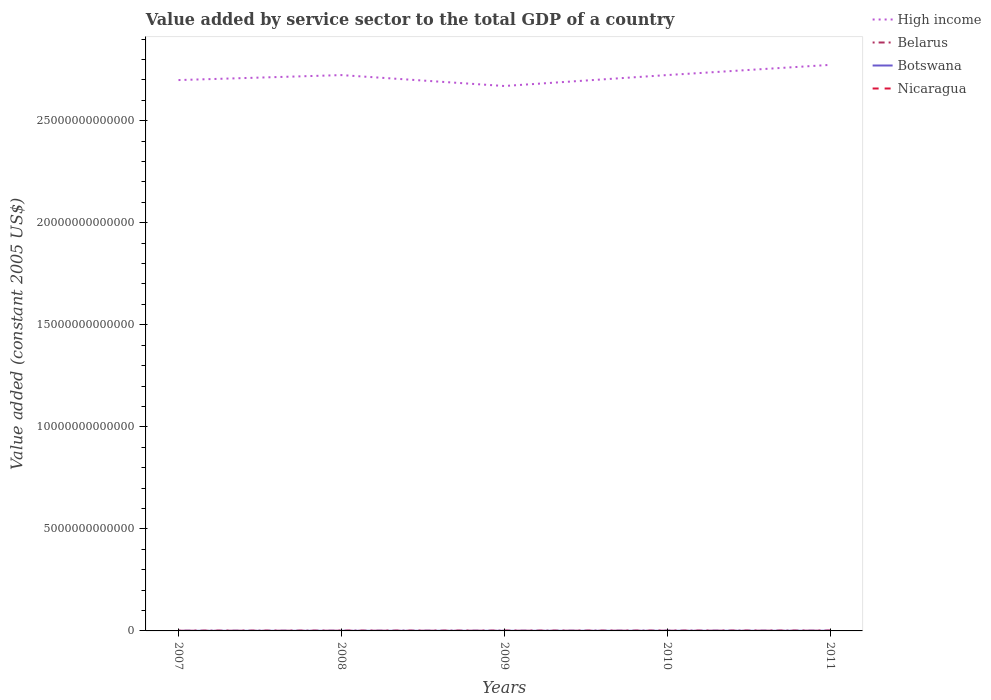Is the number of lines equal to the number of legend labels?
Keep it short and to the point. Yes. Across all years, what is the maximum value added by service sector in High income?
Your answer should be compact. 2.67e+13. What is the total value added by service sector in High income in the graph?
Your answer should be very brief. -7.44e+11. What is the difference between the highest and the second highest value added by service sector in Botswana?
Offer a terse response. 1.98e+09. What is the difference between the highest and the lowest value added by service sector in Belarus?
Offer a very short reply. 2. Is the value added by service sector in High income strictly greater than the value added by service sector in Botswana over the years?
Give a very brief answer. No. How many lines are there?
Your response must be concise. 4. What is the difference between two consecutive major ticks on the Y-axis?
Keep it short and to the point. 5.00e+12. Does the graph contain grids?
Your answer should be very brief. No. Where does the legend appear in the graph?
Your response must be concise. Top right. How many legend labels are there?
Your response must be concise. 4. What is the title of the graph?
Your response must be concise. Value added by service sector to the total GDP of a country. Does "Lao PDR" appear as one of the legend labels in the graph?
Your answer should be very brief. No. What is the label or title of the Y-axis?
Your answer should be compact. Value added (constant 2005 US$). What is the Value added (constant 2005 US$) of High income in 2007?
Provide a short and direct response. 2.70e+13. What is the Value added (constant 2005 US$) of Belarus in 2007?
Offer a terse response. 1.35e+1. What is the Value added (constant 2005 US$) in Botswana in 2007?
Provide a short and direct response. 5.49e+09. What is the Value added (constant 2005 US$) in Nicaragua in 2007?
Your answer should be compact. 3.76e+09. What is the Value added (constant 2005 US$) in High income in 2008?
Your answer should be very brief. 2.72e+13. What is the Value added (constant 2005 US$) in Belarus in 2008?
Give a very brief answer. 1.42e+1. What is the Value added (constant 2005 US$) of Botswana in 2008?
Your answer should be very brief. 6.08e+09. What is the Value added (constant 2005 US$) of Nicaragua in 2008?
Your answer should be very brief. 3.97e+09. What is the Value added (constant 2005 US$) of High income in 2009?
Provide a succinct answer. 2.67e+13. What is the Value added (constant 2005 US$) of Belarus in 2009?
Your response must be concise. 1.43e+1. What is the Value added (constant 2005 US$) in Botswana in 2009?
Give a very brief answer. 6.35e+09. What is the Value added (constant 2005 US$) in Nicaragua in 2009?
Give a very brief answer. 3.93e+09. What is the Value added (constant 2005 US$) in High income in 2010?
Give a very brief answer. 2.72e+13. What is the Value added (constant 2005 US$) of Belarus in 2010?
Make the answer very short. 1.52e+1. What is the Value added (constant 2005 US$) in Botswana in 2010?
Offer a terse response. 6.88e+09. What is the Value added (constant 2005 US$) of Nicaragua in 2010?
Your answer should be very brief. 4.13e+09. What is the Value added (constant 2005 US$) of High income in 2011?
Your answer should be compact. 2.77e+13. What is the Value added (constant 2005 US$) of Belarus in 2011?
Offer a very short reply. 1.65e+1. What is the Value added (constant 2005 US$) in Botswana in 2011?
Your answer should be compact. 7.47e+09. What is the Value added (constant 2005 US$) in Nicaragua in 2011?
Keep it short and to the point. 4.30e+09. Across all years, what is the maximum Value added (constant 2005 US$) of High income?
Ensure brevity in your answer.  2.77e+13. Across all years, what is the maximum Value added (constant 2005 US$) in Belarus?
Your response must be concise. 1.65e+1. Across all years, what is the maximum Value added (constant 2005 US$) in Botswana?
Your answer should be compact. 7.47e+09. Across all years, what is the maximum Value added (constant 2005 US$) of Nicaragua?
Make the answer very short. 4.30e+09. Across all years, what is the minimum Value added (constant 2005 US$) in High income?
Make the answer very short. 2.67e+13. Across all years, what is the minimum Value added (constant 2005 US$) of Belarus?
Offer a very short reply. 1.35e+1. Across all years, what is the minimum Value added (constant 2005 US$) of Botswana?
Your answer should be compact. 5.49e+09. Across all years, what is the minimum Value added (constant 2005 US$) in Nicaragua?
Your response must be concise. 3.76e+09. What is the total Value added (constant 2005 US$) in High income in the graph?
Keep it short and to the point. 1.36e+14. What is the total Value added (constant 2005 US$) of Belarus in the graph?
Offer a terse response. 7.37e+1. What is the total Value added (constant 2005 US$) of Botswana in the graph?
Offer a terse response. 3.23e+1. What is the total Value added (constant 2005 US$) of Nicaragua in the graph?
Your answer should be compact. 2.01e+1. What is the difference between the Value added (constant 2005 US$) of High income in 2007 and that in 2008?
Give a very brief answer. -2.44e+11. What is the difference between the Value added (constant 2005 US$) of Belarus in 2007 and that in 2008?
Offer a terse response. -6.53e+08. What is the difference between the Value added (constant 2005 US$) of Botswana in 2007 and that in 2008?
Offer a very short reply. -5.85e+08. What is the difference between the Value added (constant 2005 US$) in Nicaragua in 2007 and that in 2008?
Your answer should be compact. -2.14e+08. What is the difference between the Value added (constant 2005 US$) of High income in 2007 and that in 2009?
Your answer should be compact. 2.90e+11. What is the difference between the Value added (constant 2005 US$) in Belarus in 2007 and that in 2009?
Offer a very short reply. -7.69e+08. What is the difference between the Value added (constant 2005 US$) in Botswana in 2007 and that in 2009?
Your answer should be very brief. -8.61e+08. What is the difference between the Value added (constant 2005 US$) in Nicaragua in 2007 and that in 2009?
Your response must be concise. -1.70e+08. What is the difference between the Value added (constant 2005 US$) of High income in 2007 and that in 2010?
Offer a very short reply. -2.45e+11. What is the difference between the Value added (constant 2005 US$) of Belarus in 2007 and that in 2010?
Give a very brief answer. -1.70e+09. What is the difference between the Value added (constant 2005 US$) of Botswana in 2007 and that in 2010?
Offer a very short reply. -1.39e+09. What is the difference between the Value added (constant 2005 US$) of Nicaragua in 2007 and that in 2010?
Offer a terse response. -3.67e+08. What is the difference between the Value added (constant 2005 US$) of High income in 2007 and that in 2011?
Give a very brief answer. -7.44e+11. What is the difference between the Value added (constant 2005 US$) in Belarus in 2007 and that in 2011?
Provide a short and direct response. -2.93e+09. What is the difference between the Value added (constant 2005 US$) in Botswana in 2007 and that in 2011?
Provide a short and direct response. -1.98e+09. What is the difference between the Value added (constant 2005 US$) of Nicaragua in 2007 and that in 2011?
Give a very brief answer. -5.40e+08. What is the difference between the Value added (constant 2005 US$) of High income in 2008 and that in 2009?
Give a very brief answer. 5.34e+11. What is the difference between the Value added (constant 2005 US$) of Belarus in 2008 and that in 2009?
Provide a short and direct response. -1.16e+08. What is the difference between the Value added (constant 2005 US$) in Botswana in 2008 and that in 2009?
Give a very brief answer. -2.76e+08. What is the difference between the Value added (constant 2005 US$) in Nicaragua in 2008 and that in 2009?
Your answer should be very brief. 4.43e+07. What is the difference between the Value added (constant 2005 US$) of High income in 2008 and that in 2010?
Offer a terse response. -1.33e+09. What is the difference between the Value added (constant 2005 US$) of Belarus in 2008 and that in 2010?
Offer a terse response. -1.05e+09. What is the difference between the Value added (constant 2005 US$) in Botswana in 2008 and that in 2010?
Make the answer very short. -8.05e+08. What is the difference between the Value added (constant 2005 US$) of Nicaragua in 2008 and that in 2010?
Your answer should be compact. -1.53e+08. What is the difference between the Value added (constant 2005 US$) in High income in 2008 and that in 2011?
Provide a succinct answer. -5.01e+11. What is the difference between the Value added (constant 2005 US$) of Belarus in 2008 and that in 2011?
Offer a very short reply. -2.28e+09. What is the difference between the Value added (constant 2005 US$) in Botswana in 2008 and that in 2011?
Give a very brief answer. -1.39e+09. What is the difference between the Value added (constant 2005 US$) in Nicaragua in 2008 and that in 2011?
Your answer should be compact. -3.26e+08. What is the difference between the Value added (constant 2005 US$) of High income in 2009 and that in 2010?
Your answer should be compact. -5.36e+11. What is the difference between the Value added (constant 2005 US$) of Belarus in 2009 and that in 2010?
Your response must be concise. -9.30e+08. What is the difference between the Value added (constant 2005 US$) in Botswana in 2009 and that in 2010?
Offer a terse response. -5.29e+08. What is the difference between the Value added (constant 2005 US$) in Nicaragua in 2009 and that in 2010?
Offer a terse response. -1.97e+08. What is the difference between the Value added (constant 2005 US$) in High income in 2009 and that in 2011?
Offer a very short reply. -1.03e+12. What is the difference between the Value added (constant 2005 US$) of Belarus in 2009 and that in 2011?
Provide a short and direct response. -2.16e+09. What is the difference between the Value added (constant 2005 US$) in Botswana in 2009 and that in 2011?
Ensure brevity in your answer.  -1.12e+09. What is the difference between the Value added (constant 2005 US$) of Nicaragua in 2009 and that in 2011?
Make the answer very short. -3.70e+08. What is the difference between the Value added (constant 2005 US$) in High income in 2010 and that in 2011?
Provide a succinct answer. -4.99e+11. What is the difference between the Value added (constant 2005 US$) in Belarus in 2010 and that in 2011?
Provide a short and direct response. -1.23e+09. What is the difference between the Value added (constant 2005 US$) in Botswana in 2010 and that in 2011?
Your answer should be compact. -5.90e+08. What is the difference between the Value added (constant 2005 US$) in Nicaragua in 2010 and that in 2011?
Give a very brief answer. -1.73e+08. What is the difference between the Value added (constant 2005 US$) of High income in 2007 and the Value added (constant 2005 US$) of Belarus in 2008?
Offer a very short reply. 2.70e+13. What is the difference between the Value added (constant 2005 US$) in High income in 2007 and the Value added (constant 2005 US$) in Botswana in 2008?
Give a very brief answer. 2.70e+13. What is the difference between the Value added (constant 2005 US$) in High income in 2007 and the Value added (constant 2005 US$) in Nicaragua in 2008?
Offer a very short reply. 2.70e+13. What is the difference between the Value added (constant 2005 US$) of Belarus in 2007 and the Value added (constant 2005 US$) of Botswana in 2008?
Your answer should be compact. 7.46e+09. What is the difference between the Value added (constant 2005 US$) in Belarus in 2007 and the Value added (constant 2005 US$) in Nicaragua in 2008?
Offer a very short reply. 9.56e+09. What is the difference between the Value added (constant 2005 US$) of Botswana in 2007 and the Value added (constant 2005 US$) of Nicaragua in 2008?
Make the answer very short. 1.52e+09. What is the difference between the Value added (constant 2005 US$) of High income in 2007 and the Value added (constant 2005 US$) of Belarus in 2009?
Your answer should be very brief. 2.70e+13. What is the difference between the Value added (constant 2005 US$) in High income in 2007 and the Value added (constant 2005 US$) in Botswana in 2009?
Provide a short and direct response. 2.70e+13. What is the difference between the Value added (constant 2005 US$) of High income in 2007 and the Value added (constant 2005 US$) of Nicaragua in 2009?
Keep it short and to the point. 2.70e+13. What is the difference between the Value added (constant 2005 US$) of Belarus in 2007 and the Value added (constant 2005 US$) of Botswana in 2009?
Your answer should be very brief. 7.18e+09. What is the difference between the Value added (constant 2005 US$) of Belarus in 2007 and the Value added (constant 2005 US$) of Nicaragua in 2009?
Make the answer very short. 9.61e+09. What is the difference between the Value added (constant 2005 US$) of Botswana in 2007 and the Value added (constant 2005 US$) of Nicaragua in 2009?
Provide a succinct answer. 1.56e+09. What is the difference between the Value added (constant 2005 US$) of High income in 2007 and the Value added (constant 2005 US$) of Belarus in 2010?
Provide a short and direct response. 2.70e+13. What is the difference between the Value added (constant 2005 US$) of High income in 2007 and the Value added (constant 2005 US$) of Botswana in 2010?
Keep it short and to the point. 2.70e+13. What is the difference between the Value added (constant 2005 US$) of High income in 2007 and the Value added (constant 2005 US$) of Nicaragua in 2010?
Offer a terse response. 2.70e+13. What is the difference between the Value added (constant 2005 US$) of Belarus in 2007 and the Value added (constant 2005 US$) of Botswana in 2010?
Provide a short and direct response. 6.66e+09. What is the difference between the Value added (constant 2005 US$) in Belarus in 2007 and the Value added (constant 2005 US$) in Nicaragua in 2010?
Give a very brief answer. 9.41e+09. What is the difference between the Value added (constant 2005 US$) in Botswana in 2007 and the Value added (constant 2005 US$) in Nicaragua in 2010?
Give a very brief answer. 1.37e+09. What is the difference between the Value added (constant 2005 US$) in High income in 2007 and the Value added (constant 2005 US$) in Belarus in 2011?
Make the answer very short. 2.70e+13. What is the difference between the Value added (constant 2005 US$) in High income in 2007 and the Value added (constant 2005 US$) in Botswana in 2011?
Give a very brief answer. 2.70e+13. What is the difference between the Value added (constant 2005 US$) in High income in 2007 and the Value added (constant 2005 US$) in Nicaragua in 2011?
Your answer should be very brief. 2.70e+13. What is the difference between the Value added (constant 2005 US$) of Belarus in 2007 and the Value added (constant 2005 US$) of Botswana in 2011?
Your answer should be very brief. 6.07e+09. What is the difference between the Value added (constant 2005 US$) in Belarus in 2007 and the Value added (constant 2005 US$) in Nicaragua in 2011?
Keep it short and to the point. 9.24e+09. What is the difference between the Value added (constant 2005 US$) of Botswana in 2007 and the Value added (constant 2005 US$) of Nicaragua in 2011?
Your answer should be compact. 1.19e+09. What is the difference between the Value added (constant 2005 US$) in High income in 2008 and the Value added (constant 2005 US$) in Belarus in 2009?
Your answer should be compact. 2.72e+13. What is the difference between the Value added (constant 2005 US$) in High income in 2008 and the Value added (constant 2005 US$) in Botswana in 2009?
Your answer should be very brief. 2.72e+13. What is the difference between the Value added (constant 2005 US$) in High income in 2008 and the Value added (constant 2005 US$) in Nicaragua in 2009?
Provide a short and direct response. 2.72e+13. What is the difference between the Value added (constant 2005 US$) of Belarus in 2008 and the Value added (constant 2005 US$) of Botswana in 2009?
Your response must be concise. 7.84e+09. What is the difference between the Value added (constant 2005 US$) of Belarus in 2008 and the Value added (constant 2005 US$) of Nicaragua in 2009?
Make the answer very short. 1.03e+1. What is the difference between the Value added (constant 2005 US$) in Botswana in 2008 and the Value added (constant 2005 US$) in Nicaragua in 2009?
Offer a very short reply. 2.15e+09. What is the difference between the Value added (constant 2005 US$) in High income in 2008 and the Value added (constant 2005 US$) in Belarus in 2010?
Your response must be concise. 2.72e+13. What is the difference between the Value added (constant 2005 US$) of High income in 2008 and the Value added (constant 2005 US$) of Botswana in 2010?
Offer a very short reply. 2.72e+13. What is the difference between the Value added (constant 2005 US$) in High income in 2008 and the Value added (constant 2005 US$) in Nicaragua in 2010?
Provide a short and direct response. 2.72e+13. What is the difference between the Value added (constant 2005 US$) of Belarus in 2008 and the Value added (constant 2005 US$) of Botswana in 2010?
Offer a very short reply. 7.31e+09. What is the difference between the Value added (constant 2005 US$) in Belarus in 2008 and the Value added (constant 2005 US$) in Nicaragua in 2010?
Ensure brevity in your answer.  1.01e+1. What is the difference between the Value added (constant 2005 US$) in Botswana in 2008 and the Value added (constant 2005 US$) in Nicaragua in 2010?
Ensure brevity in your answer.  1.95e+09. What is the difference between the Value added (constant 2005 US$) in High income in 2008 and the Value added (constant 2005 US$) in Belarus in 2011?
Keep it short and to the point. 2.72e+13. What is the difference between the Value added (constant 2005 US$) in High income in 2008 and the Value added (constant 2005 US$) in Botswana in 2011?
Give a very brief answer. 2.72e+13. What is the difference between the Value added (constant 2005 US$) of High income in 2008 and the Value added (constant 2005 US$) of Nicaragua in 2011?
Keep it short and to the point. 2.72e+13. What is the difference between the Value added (constant 2005 US$) in Belarus in 2008 and the Value added (constant 2005 US$) in Botswana in 2011?
Keep it short and to the point. 6.72e+09. What is the difference between the Value added (constant 2005 US$) of Belarus in 2008 and the Value added (constant 2005 US$) of Nicaragua in 2011?
Your answer should be very brief. 9.89e+09. What is the difference between the Value added (constant 2005 US$) of Botswana in 2008 and the Value added (constant 2005 US$) of Nicaragua in 2011?
Offer a terse response. 1.78e+09. What is the difference between the Value added (constant 2005 US$) of High income in 2009 and the Value added (constant 2005 US$) of Belarus in 2010?
Make the answer very short. 2.67e+13. What is the difference between the Value added (constant 2005 US$) of High income in 2009 and the Value added (constant 2005 US$) of Botswana in 2010?
Make the answer very short. 2.67e+13. What is the difference between the Value added (constant 2005 US$) of High income in 2009 and the Value added (constant 2005 US$) of Nicaragua in 2010?
Give a very brief answer. 2.67e+13. What is the difference between the Value added (constant 2005 US$) in Belarus in 2009 and the Value added (constant 2005 US$) in Botswana in 2010?
Ensure brevity in your answer.  7.42e+09. What is the difference between the Value added (constant 2005 US$) in Belarus in 2009 and the Value added (constant 2005 US$) in Nicaragua in 2010?
Give a very brief answer. 1.02e+1. What is the difference between the Value added (constant 2005 US$) in Botswana in 2009 and the Value added (constant 2005 US$) in Nicaragua in 2010?
Make the answer very short. 2.23e+09. What is the difference between the Value added (constant 2005 US$) in High income in 2009 and the Value added (constant 2005 US$) in Belarus in 2011?
Provide a short and direct response. 2.67e+13. What is the difference between the Value added (constant 2005 US$) of High income in 2009 and the Value added (constant 2005 US$) of Botswana in 2011?
Give a very brief answer. 2.67e+13. What is the difference between the Value added (constant 2005 US$) in High income in 2009 and the Value added (constant 2005 US$) in Nicaragua in 2011?
Provide a short and direct response. 2.67e+13. What is the difference between the Value added (constant 2005 US$) in Belarus in 2009 and the Value added (constant 2005 US$) in Botswana in 2011?
Make the answer very short. 6.83e+09. What is the difference between the Value added (constant 2005 US$) in Belarus in 2009 and the Value added (constant 2005 US$) in Nicaragua in 2011?
Give a very brief answer. 1.00e+1. What is the difference between the Value added (constant 2005 US$) of Botswana in 2009 and the Value added (constant 2005 US$) of Nicaragua in 2011?
Ensure brevity in your answer.  2.05e+09. What is the difference between the Value added (constant 2005 US$) of High income in 2010 and the Value added (constant 2005 US$) of Belarus in 2011?
Make the answer very short. 2.72e+13. What is the difference between the Value added (constant 2005 US$) of High income in 2010 and the Value added (constant 2005 US$) of Botswana in 2011?
Make the answer very short. 2.72e+13. What is the difference between the Value added (constant 2005 US$) of High income in 2010 and the Value added (constant 2005 US$) of Nicaragua in 2011?
Provide a succinct answer. 2.72e+13. What is the difference between the Value added (constant 2005 US$) of Belarus in 2010 and the Value added (constant 2005 US$) of Botswana in 2011?
Make the answer very short. 7.76e+09. What is the difference between the Value added (constant 2005 US$) of Belarus in 2010 and the Value added (constant 2005 US$) of Nicaragua in 2011?
Your answer should be very brief. 1.09e+1. What is the difference between the Value added (constant 2005 US$) of Botswana in 2010 and the Value added (constant 2005 US$) of Nicaragua in 2011?
Ensure brevity in your answer.  2.58e+09. What is the average Value added (constant 2005 US$) of High income per year?
Provide a succinct answer. 2.72e+13. What is the average Value added (constant 2005 US$) of Belarus per year?
Your response must be concise. 1.47e+1. What is the average Value added (constant 2005 US$) of Botswana per year?
Give a very brief answer. 6.46e+09. What is the average Value added (constant 2005 US$) in Nicaragua per year?
Your answer should be very brief. 4.02e+09. In the year 2007, what is the difference between the Value added (constant 2005 US$) in High income and Value added (constant 2005 US$) in Belarus?
Your answer should be compact. 2.70e+13. In the year 2007, what is the difference between the Value added (constant 2005 US$) of High income and Value added (constant 2005 US$) of Botswana?
Your response must be concise. 2.70e+13. In the year 2007, what is the difference between the Value added (constant 2005 US$) in High income and Value added (constant 2005 US$) in Nicaragua?
Offer a very short reply. 2.70e+13. In the year 2007, what is the difference between the Value added (constant 2005 US$) in Belarus and Value added (constant 2005 US$) in Botswana?
Provide a succinct answer. 8.04e+09. In the year 2007, what is the difference between the Value added (constant 2005 US$) in Belarus and Value added (constant 2005 US$) in Nicaragua?
Make the answer very short. 9.78e+09. In the year 2007, what is the difference between the Value added (constant 2005 US$) in Botswana and Value added (constant 2005 US$) in Nicaragua?
Provide a short and direct response. 1.73e+09. In the year 2008, what is the difference between the Value added (constant 2005 US$) in High income and Value added (constant 2005 US$) in Belarus?
Keep it short and to the point. 2.72e+13. In the year 2008, what is the difference between the Value added (constant 2005 US$) of High income and Value added (constant 2005 US$) of Botswana?
Your response must be concise. 2.72e+13. In the year 2008, what is the difference between the Value added (constant 2005 US$) in High income and Value added (constant 2005 US$) in Nicaragua?
Provide a short and direct response. 2.72e+13. In the year 2008, what is the difference between the Value added (constant 2005 US$) in Belarus and Value added (constant 2005 US$) in Botswana?
Give a very brief answer. 8.11e+09. In the year 2008, what is the difference between the Value added (constant 2005 US$) in Belarus and Value added (constant 2005 US$) in Nicaragua?
Offer a very short reply. 1.02e+1. In the year 2008, what is the difference between the Value added (constant 2005 US$) of Botswana and Value added (constant 2005 US$) of Nicaragua?
Keep it short and to the point. 2.10e+09. In the year 2009, what is the difference between the Value added (constant 2005 US$) of High income and Value added (constant 2005 US$) of Belarus?
Offer a very short reply. 2.67e+13. In the year 2009, what is the difference between the Value added (constant 2005 US$) of High income and Value added (constant 2005 US$) of Botswana?
Offer a terse response. 2.67e+13. In the year 2009, what is the difference between the Value added (constant 2005 US$) of High income and Value added (constant 2005 US$) of Nicaragua?
Your answer should be compact. 2.67e+13. In the year 2009, what is the difference between the Value added (constant 2005 US$) of Belarus and Value added (constant 2005 US$) of Botswana?
Your answer should be very brief. 7.95e+09. In the year 2009, what is the difference between the Value added (constant 2005 US$) in Belarus and Value added (constant 2005 US$) in Nicaragua?
Your answer should be very brief. 1.04e+1. In the year 2009, what is the difference between the Value added (constant 2005 US$) in Botswana and Value added (constant 2005 US$) in Nicaragua?
Keep it short and to the point. 2.42e+09. In the year 2010, what is the difference between the Value added (constant 2005 US$) of High income and Value added (constant 2005 US$) of Belarus?
Offer a terse response. 2.72e+13. In the year 2010, what is the difference between the Value added (constant 2005 US$) in High income and Value added (constant 2005 US$) in Botswana?
Offer a very short reply. 2.72e+13. In the year 2010, what is the difference between the Value added (constant 2005 US$) of High income and Value added (constant 2005 US$) of Nicaragua?
Keep it short and to the point. 2.72e+13. In the year 2010, what is the difference between the Value added (constant 2005 US$) of Belarus and Value added (constant 2005 US$) of Botswana?
Provide a succinct answer. 8.35e+09. In the year 2010, what is the difference between the Value added (constant 2005 US$) of Belarus and Value added (constant 2005 US$) of Nicaragua?
Provide a short and direct response. 1.11e+1. In the year 2010, what is the difference between the Value added (constant 2005 US$) of Botswana and Value added (constant 2005 US$) of Nicaragua?
Ensure brevity in your answer.  2.76e+09. In the year 2011, what is the difference between the Value added (constant 2005 US$) of High income and Value added (constant 2005 US$) of Belarus?
Keep it short and to the point. 2.77e+13. In the year 2011, what is the difference between the Value added (constant 2005 US$) of High income and Value added (constant 2005 US$) of Botswana?
Your answer should be very brief. 2.77e+13. In the year 2011, what is the difference between the Value added (constant 2005 US$) of High income and Value added (constant 2005 US$) of Nicaragua?
Provide a short and direct response. 2.77e+13. In the year 2011, what is the difference between the Value added (constant 2005 US$) of Belarus and Value added (constant 2005 US$) of Botswana?
Keep it short and to the point. 9.00e+09. In the year 2011, what is the difference between the Value added (constant 2005 US$) of Belarus and Value added (constant 2005 US$) of Nicaragua?
Your answer should be compact. 1.22e+1. In the year 2011, what is the difference between the Value added (constant 2005 US$) in Botswana and Value added (constant 2005 US$) in Nicaragua?
Your response must be concise. 3.17e+09. What is the ratio of the Value added (constant 2005 US$) in Belarus in 2007 to that in 2008?
Offer a terse response. 0.95. What is the ratio of the Value added (constant 2005 US$) in Botswana in 2007 to that in 2008?
Provide a short and direct response. 0.9. What is the ratio of the Value added (constant 2005 US$) in Nicaragua in 2007 to that in 2008?
Keep it short and to the point. 0.95. What is the ratio of the Value added (constant 2005 US$) in High income in 2007 to that in 2009?
Make the answer very short. 1.01. What is the ratio of the Value added (constant 2005 US$) of Belarus in 2007 to that in 2009?
Ensure brevity in your answer.  0.95. What is the ratio of the Value added (constant 2005 US$) of Botswana in 2007 to that in 2009?
Your answer should be compact. 0.86. What is the ratio of the Value added (constant 2005 US$) of Nicaragua in 2007 to that in 2009?
Make the answer very short. 0.96. What is the ratio of the Value added (constant 2005 US$) of High income in 2007 to that in 2010?
Ensure brevity in your answer.  0.99. What is the ratio of the Value added (constant 2005 US$) in Belarus in 2007 to that in 2010?
Provide a short and direct response. 0.89. What is the ratio of the Value added (constant 2005 US$) in Botswana in 2007 to that in 2010?
Provide a succinct answer. 0.8. What is the ratio of the Value added (constant 2005 US$) in Nicaragua in 2007 to that in 2010?
Keep it short and to the point. 0.91. What is the ratio of the Value added (constant 2005 US$) of High income in 2007 to that in 2011?
Your response must be concise. 0.97. What is the ratio of the Value added (constant 2005 US$) of Belarus in 2007 to that in 2011?
Make the answer very short. 0.82. What is the ratio of the Value added (constant 2005 US$) of Botswana in 2007 to that in 2011?
Keep it short and to the point. 0.74. What is the ratio of the Value added (constant 2005 US$) of Nicaragua in 2007 to that in 2011?
Your answer should be compact. 0.87. What is the ratio of the Value added (constant 2005 US$) of Botswana in 2008 to that in 2009?
Keep it short and to the point. 0.96. What is the ratio of the Value added (constant 2005 US$) in Nicaragua in 2008 to that in 2009?
Offer a terse response. 1.01. What is the ratio of the Value added (constant 2005 US$) in High income in 2008 to that in 2010?
Your response must be concise. 1. What is the ratio of the Value added (constant 2005 US$) of Belarus in 2008 to that in 2010?
Your answer should be very brief. 0.93. What is the ratio of the Value added (constant 2005 US$) of Botswana in 2008 to that in 2010?
Ensure brevity in your answer.  0.88. What is the ratio of the Value added (constant 2005 US$) in High income in 2008 to that in 2011?
Provide a short and direct response. 0.98. What is the ratio of the Value added (constant 2005 US$) of Belarus in 2008 to that in 2011?
Offer a very short reply. 0.86. What is the ratio of the Value added (constant 2005 US$) in Botswana in 2008 to that in 2011?
Provide a short and direct response. 0.81. What is the ratio of the Value added (constant 2005 US$) of Nicaragua in 2008 to that in 2011?
Your answer should be very brief. 0.92. What is the ratio of the Value added (constant 2005 US$) of High income in 2009 to that in 2010?
Provide a short and direct response. 0.98. What is the ratio of the Value added (constant 2005 US$) in Belarus in 2009 to that in 2010?
Ensure brevity in your answer.  0.94. What is the ratio of the Value added (constant 2005 US$) in Botswana in 2009 to that in 2010?
Your answer should be compact. 0.92. What is the ratio of the Value added (constant 2005 US$) of Nicaragua in 2009 to that in 2010?
Your answer should be very brief. 0.95. What is the ratio of the Value added (constant 2005 US$) in High income in 2009 to that in 2011?
Your answer should be very brief. 0.96. What is the ratio of the Value added (constant 2005 US$) of Belarus in 2009 to that in 2011?
Offer a very short reply. 0.87. What is the ratio of the Value added (constant 2005 US$) of Botswana in 2009 to that in 2011?
Your answer should be compact. 0.85. What is the ratio of the Value added (constant 2005 US$) in Nicaragua in 2009 to that in 2011?
Make the answer very short. 0.91. What is the ratio of the Value added (constant 2005 US$) of Belarus in 2010 to that in 2011?
Give a very brief answer. 0.93. What is the ratio of the Value added (constant 2005 US$) in Botswana in 2010 to that in 2011?
Make the answer very short. 0.92. What is the ratio of the Value added (constant 2005 US$) in Nicaragua in 2010 to that in 2011?
Keep it short and to the point. 0.96. What is the difference between the highest and the second highest Value added (constant 2005 US$) of High income?
Offer a terse response. 4.99e+11. What is the difference between the highest and the second highest Value added (constant 2005 US$) of Belarus?
Your response must be concise. 1.23e+09. What is the difference between the highest and the second highest Value added (constant 2005 US$) of Botswana?
Ensure brevity in your answer.  5.90e+08. What is the difference between the highest and the second highest Value added (constant 2005 US$) of Nicaragua?
Your response must be concise. 1.73e+08. What is the difference between the highest and the lowest Value added (constant 2005 US$) of High income?
Your answer should be compact. 1.03e+12. What is the difference between the highest and the lowest Value added (constant 2005 US$) of Belarus?
Your response must be concise. 2.93e+09. What is the difference between the highest and the lowest Value added (constant 2005 US$) of Botswana?
Offer a terse response. 1.98e+09. What is the difference between the highest and the lowest Value added (constant 2005 US$) of Nicaragua?
Give a very brief answer. 5.40e+08. 